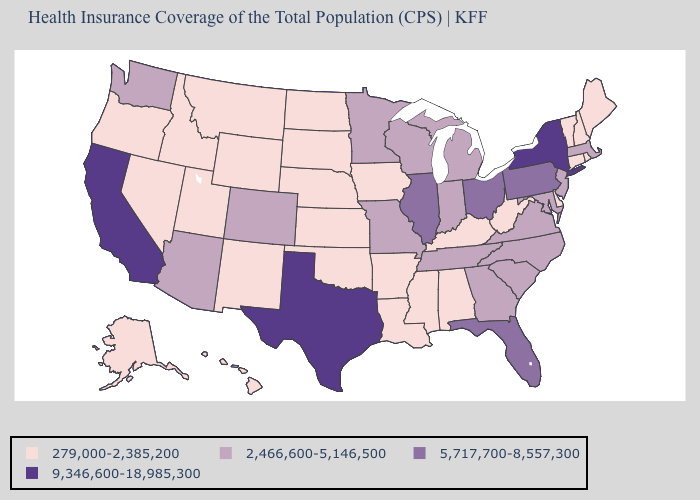Does New Mexico have a lower value than Minnesota?
Give a very brief answer. Yes. Does Alaska have the lowest value in the West?
Concise answer only. Yes. What is the value of Wyoming?
Short answer required. 279,000-2,385,200. Name the states that have a value in the range 2,466,600-5,146,500?
Quick response, please. Arizona, Colorado, Georgia, Indiana, Maryland, Massachusetts, Michigan, Minnesota, Missouri, New Jersey, North Carolina, South Carolina, Tennessee, Virginia, Washington, Wisconsin. Which states hav the highest value in the South?
Write a very short answer. Texas. Does California have the highest value in the USA?
Quick response, please. Yes. Which states have the lowest value in the USA?
Give a very brief answer. Alabama, Alaska, Arkansas, Connecticut, Delaware, Hawaii, Idaho, Iowa, Kansas, Kentucky, Louisiana, Maine, Mississippi, Montana, Nebraska, Nevada, New Hampshire, New Mexico, North Dakota, Oklahoma, Oregon, Rhode Island, South Dakota, Utah, Vermont, West Virginia, Wyoming. Name the states that have a value in the range 5,717,700-8,557,300?
Be succinct. Florida, Illinois, Ohio, Pennsylvania. Among the states that border Delaware , does Pennsylvania have the highest value?
Keep it brief. Yes. What is the value of Massachusetts?
Concise answer only. 2,466,600-5,146,500. Does Oklahoma have a lower value than Indiana?
Write a very short answer. Yes. What is the value of Pennsylvania?
Write a very short answer. 5,717,700-8,557,300. What is the highest value in states that border Maine?
Give a very brief answer. 279,000-2,385,200. Does Alaska have the same value as Delaware?
Write a very short answer. Yes. 